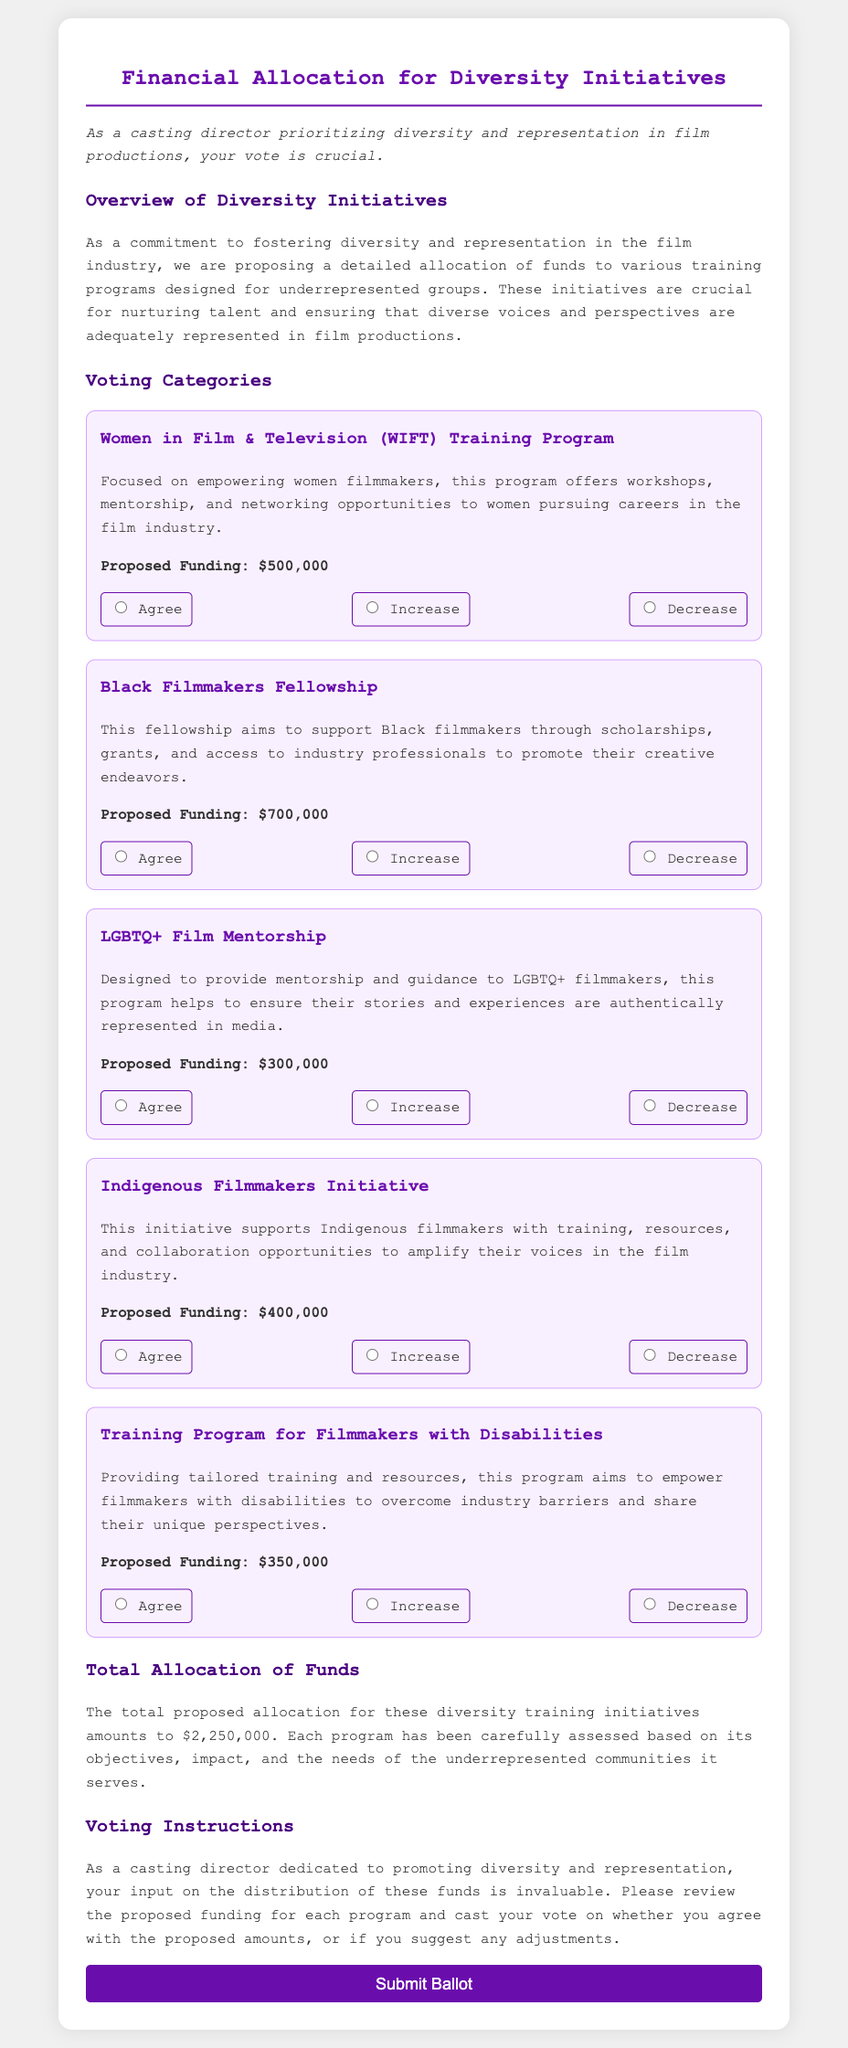What is the total proposed allocation for diversity initiatives? The total proposed allocation is mentioned in the document as $2,250,000.
Answer: $2,250,000 How much funding is proposed for the Black Filmmakers Fellowship? The proposed funding for the Black Filmmakers Fellowship is specified in the document.
Answer: $700,000 What program focuses on empowering women filmmakers? The program which focuses on empowering women filmmakers is named in the document.
Answer: Women in Film & Television (WIFT) Training Program Which program has a proposed funding amount of $300,000? The document states the proposed amount of funding for each program, allowing us to identify the specific program.
Answer: LGBTQ+ Film Mentorship What initiative supports Indigenous filmmakers? The initiative focused on supporting Indigenous filmmakers is clearly stated in the document.
Answer: Indigenous Filmmakers Initiative Which training program aims to assist filmmakers with disabilities? The document names a program designed specifically for this group of filmmakers.
Answer: Training Program for Filmmakers with Disabilities If you agree with the proposed funding for a program, what are the voting options available? The document outlines the available options for voting on each program's funding, reflecting your stance.
Answer: Agree, Increase, Decrease How many training programs were proposed for funding? The document lists the number of distinct programs proposed for funding, leading to this numerical answer.
Answer: Five What is the key focus of the LGBTQ+ Film Mentorship program? The document describes the aim of the program to understand its purpose better.
Answer: Mentorship and guidance 